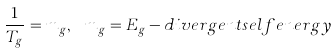Convert formula to latex. <formula><loc_0><loc_0><loc_500><loc_500>\frac { 1 } { T _ { g } } = m _ { g } , \ m _ { g } = E _ { g } - d i v e r g e n t s e l f e n e r g y</formula> 